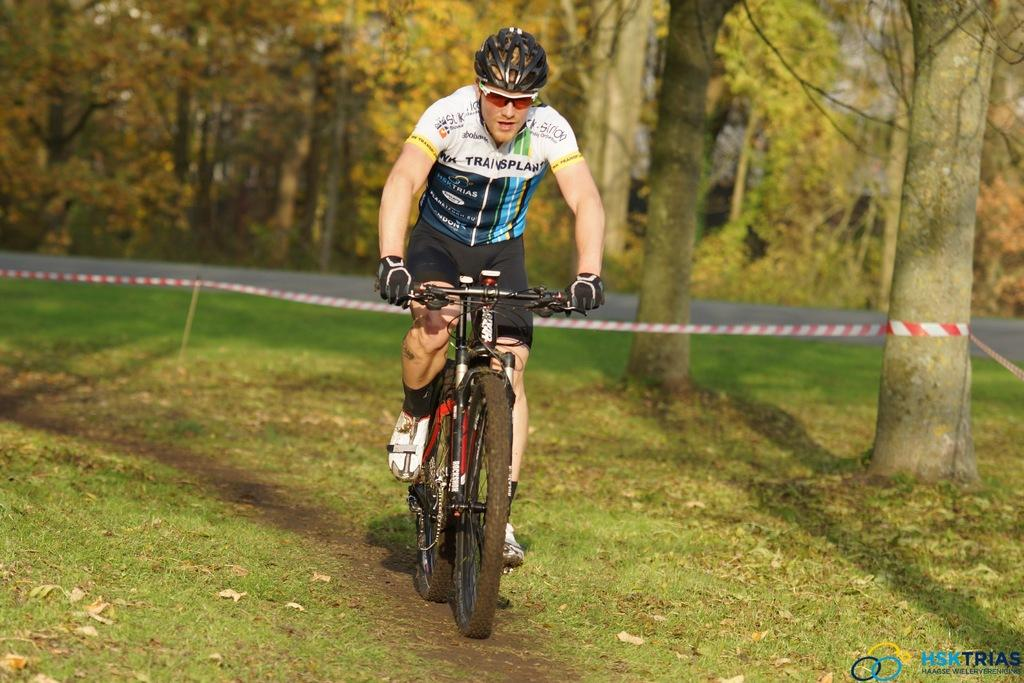What is the man in the image doing? The man is riding a bicycle in the image. What safety precaution is the man taking while riding the bicycle? The man is wearing a helmet. What type of environment is the image set in? The image appears to be set in a forest area. What can be seen in the background of the image? There are trees and a road visible in the background of the image. What type of dirt is visible on the man's clothes in the image? There is no dirt visible on the man's clothes in the image. What punishment is the man receiving for riding the bicycle in the image? There is no indication of any punishment in the image; the man is simply riding a bicycle. 